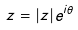Convert formula to latex. <formula><loc_0><loc_0><loc_500><loc_500>z = | z | e ^ { i \theta }</formula> 